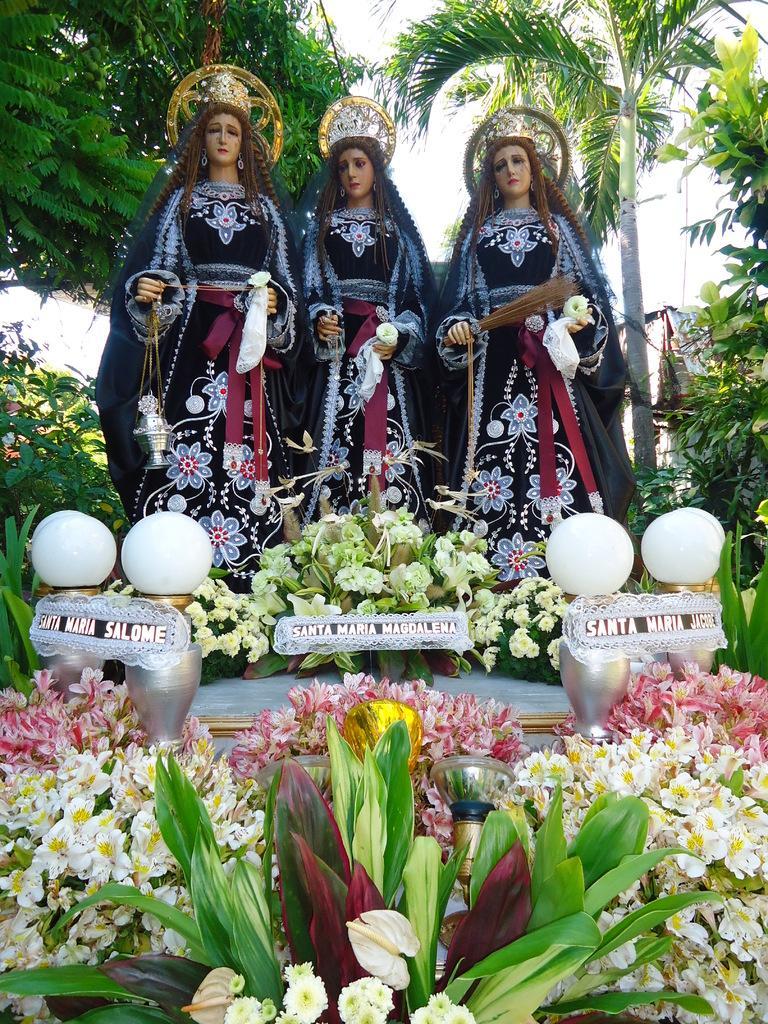How would you summarize this image in a sentence or two? In this image I can see the status of women. Here I can see flower plants and white color objects. In the background I can see the sky. 